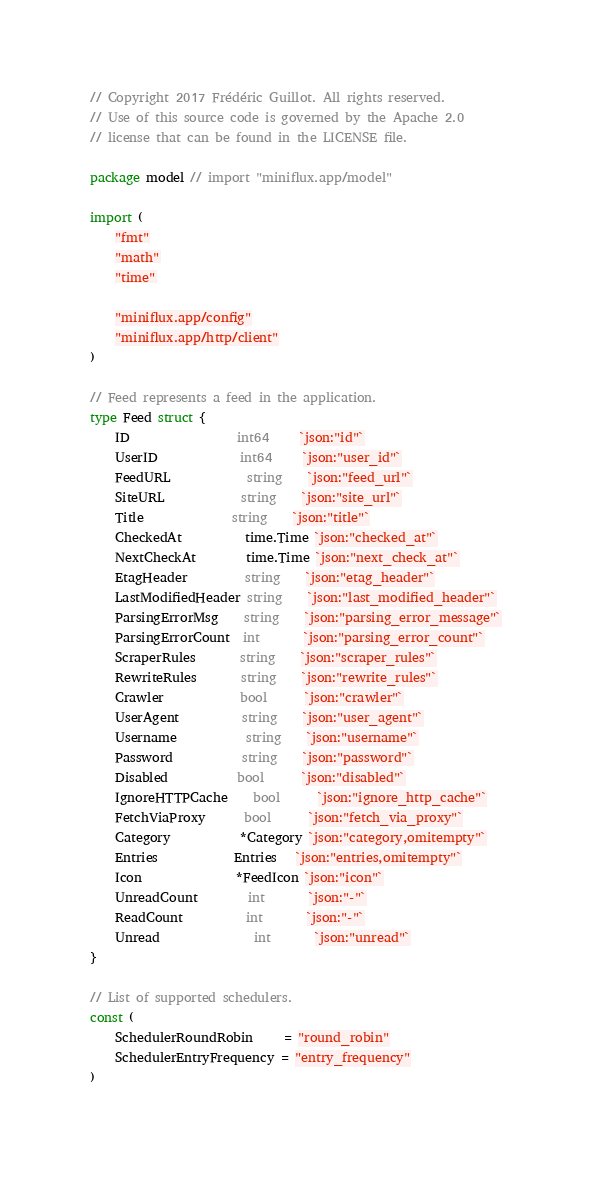<code> <loc_0><loc_0><loc_500><loc_500><_Go_>// Copyright 2017 Frédéric Guillot. All rights reserved.
// Use of this source code is governed by the Apache 2.0
// license that can be found in the LICENSE file.

package model // import "miniflux.app/model"

import (
	"fmt"
	"math"
	"time"

	"miniflux.app/config"
	"miniflux.app/http/client"
)

// Feed represents a feed in the application.
type Feed struct {
	ID                 int64     `json:"id"`
	UserID             int64     `json:"user_id"`
	FeedURL            string    `json:"feed_url"`
	SiteURL            string    `json:"site_url"`
	Title              string    `json:"title"`
	CheckedAt          time.Time `json:"checked_at"`
	NextCheckAt        time.Time `json:"next_check_at"`
	EtagHeader         string    `json:"etag_header"`
	LastModifiedHeader string    `json:"last_modified_header"`
	ParsingErrorMsg    string    `json:"parsing_error_message"`
	ParsingErrorCount  int       `json:"parsing_error_count"`
	ScraperRules       string    `json:"scraper_rules"`
	RewriteRules       string    `json:"rewrite_rules"`
	Crawler            bool      `json:"crawler"`
	UserAgent          string    `json:"user_agent"`
	Username           string    `json:"username"`
	Password           string    `json:"password"`
	Disabled           bool      `json:"disabled"`
	IgnoreHTTPCache    bool      `json:"ignore_http_cache"`
	FetchViaProxy      bool      `json:"fetch_via_proxy"`
	Category           *Category `json:"category,omitempty"`
	Entries            Entries   `json:"entries,omitempty"`
	Icon               *FeedIcon `json:"icon"`
	UnreadCount        int       `json:"-"`
	ReadCount          int       `json:"-"`
	Unread			   int       `json:"unread"`
}

// List of supported schedulers.
const (
	SchedulerRoundRobin     = "round_robin"
	SchedulerEntryFrequency = "entry_frequency"
)
</code> 